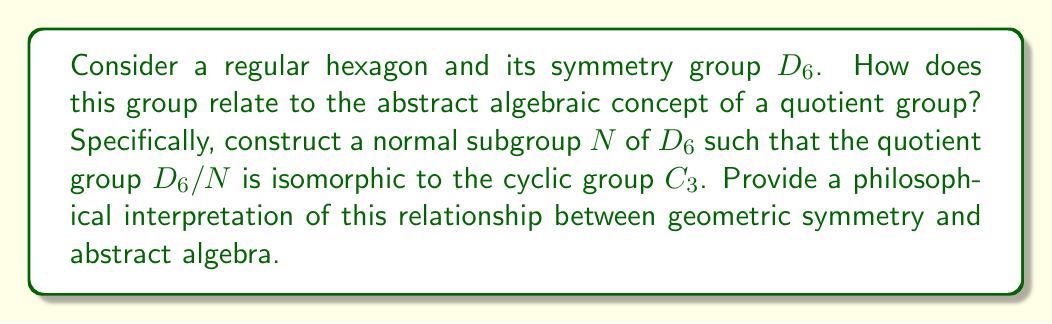Can you answer this question? Let's approach this step-by-step:

1) First, recall that the symmetry group of a regular hexagon, $D_6$, has 12 elements: 6 rotations and 6 reflections.

2) The rotations form a cyclic subgroup of order 6, which we can call $R_6$. The elements of $R_6$ are rotations by multiples of 60°.

3) To find a normal subgroup $N$ such that $D_6/N \cong C_3$, we need a subgroup of order 4 (since $|D_6|/|N| = |C_3| = 3$).

4) Consider the subgroup $N$ consisting of the identity, the 180° rotation, and the three reflections across axes passing through opposite vertices.

5) To show that $N$ is normal, we need to verify that $gNg^{-1} = N$ for all $g \in D_6$. This can be done by considering the action of conjugation on each element of $N$.

6) Once we establish that $N$ is normal, we can form the quotient group $D_6/N$. This group has three cosets: $N$, $aN$, and $a^2N$, where $a$ is a 60° rotation.

7) The operation table of $D_6/N$ is isomorphic to that of $C_3$, thus establishing $D_6/N \cong C_3$.

Philosophical Interpretation:
This relationship between geometric symmetry and abstract algebra illustrates a profound connection between the concrete and the abstract. The symmetries of a physical object (the hexagon) give rise to an abstract algebraic structure (the group $D_6$). Furthermore, by considering a particular subgroup and forming a quotient, we reveal a hidden cyclic structure ($C_3$) within the more complex dihedral group.

This process of abstraction and quotient formation mirrors philosophical concepts of essence and form. The quotient group $D_6/N$ can be seen as distilling the "essential" rotational symmetry of the hexagon, abstracting away from the "form" of its reflectional symmetries. This echoes Plato's theory of Forms, where the abstract (the quotient group) captures a fundamental truth about the concrete (the hexagon's symmetry).

Moreover, the isomorphism between $D_6/N$ and $C_3$ suggests a unity underlying seemingly different mathematical structures, resonating with monist philosophical traditions that seek a fundamental unity in diverse phenomena.
Answer: The normal subgroup $N$ of $D_6$ that yields $D_6/N \cong C_3$ is the subgroup of order 4 containing the identity, the 180° rotation, and the three reflections across axes passing through opposite vertices of the hexagon. 